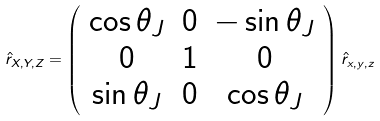<formula> <loc_0><loc_0><loc_500><loc_500>\hat { r } _ { X , Y , Z } = \left ( \begin{array} { c c c } \cos \theta _ { J } & 0 & - \sin \theta _ { J } \\ 0 & 1 & 0 \\ \sin \theta _ { J } & 0 & \cos \theta _ { J } \end{array} \right ) \hat { r } _ { x , y , z }</formula> 